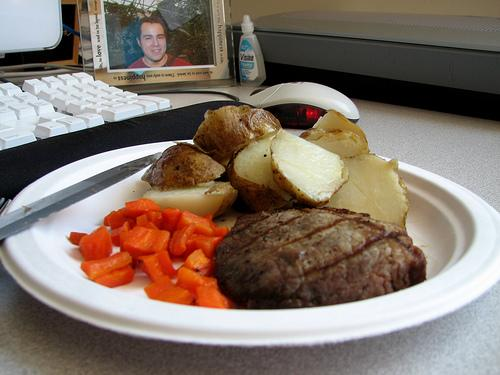Where is this kind of plate normally used? table 